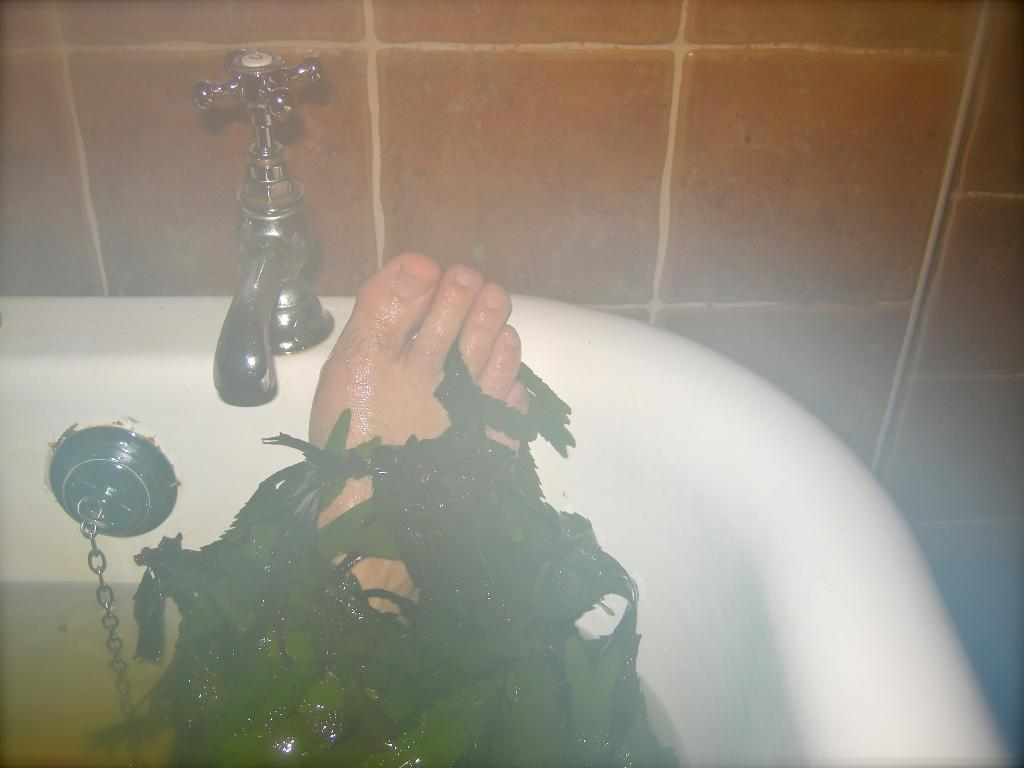What is the main object in the image? There is a tap and a sink in the image. What is the person's leg doing in the sink? A person's leg is in the sink. What is on the leg? Green color leaves are on the leg. What is connected to the tap? There is a chain visible in the image, which is connected to the tap. What is the purpose of the sink? The sink is likely used for washing or cleaning purposes. What type of song is being sung by the cakes in the image? There are no cakes present in the image, and therefore no singing can be observed. 